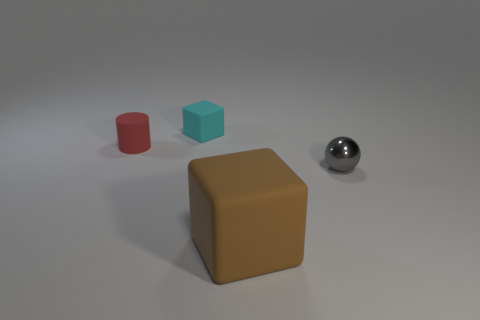Add 3 large gray metal things. How many objects exist? 7 Subtract all cylinders. How many objects are left? 3 Add 3 small cyan spheres. How many small cyan spheres exist? 3 Subtract 0 green cubes. How many objects are left? 4 Subtract all tiny cyan rubber blocks. Subtract all small cyan rubber objects. How many objects are left? 2 Add 3 small rubber cylinders. How many small rubber cylinders are left? 4 